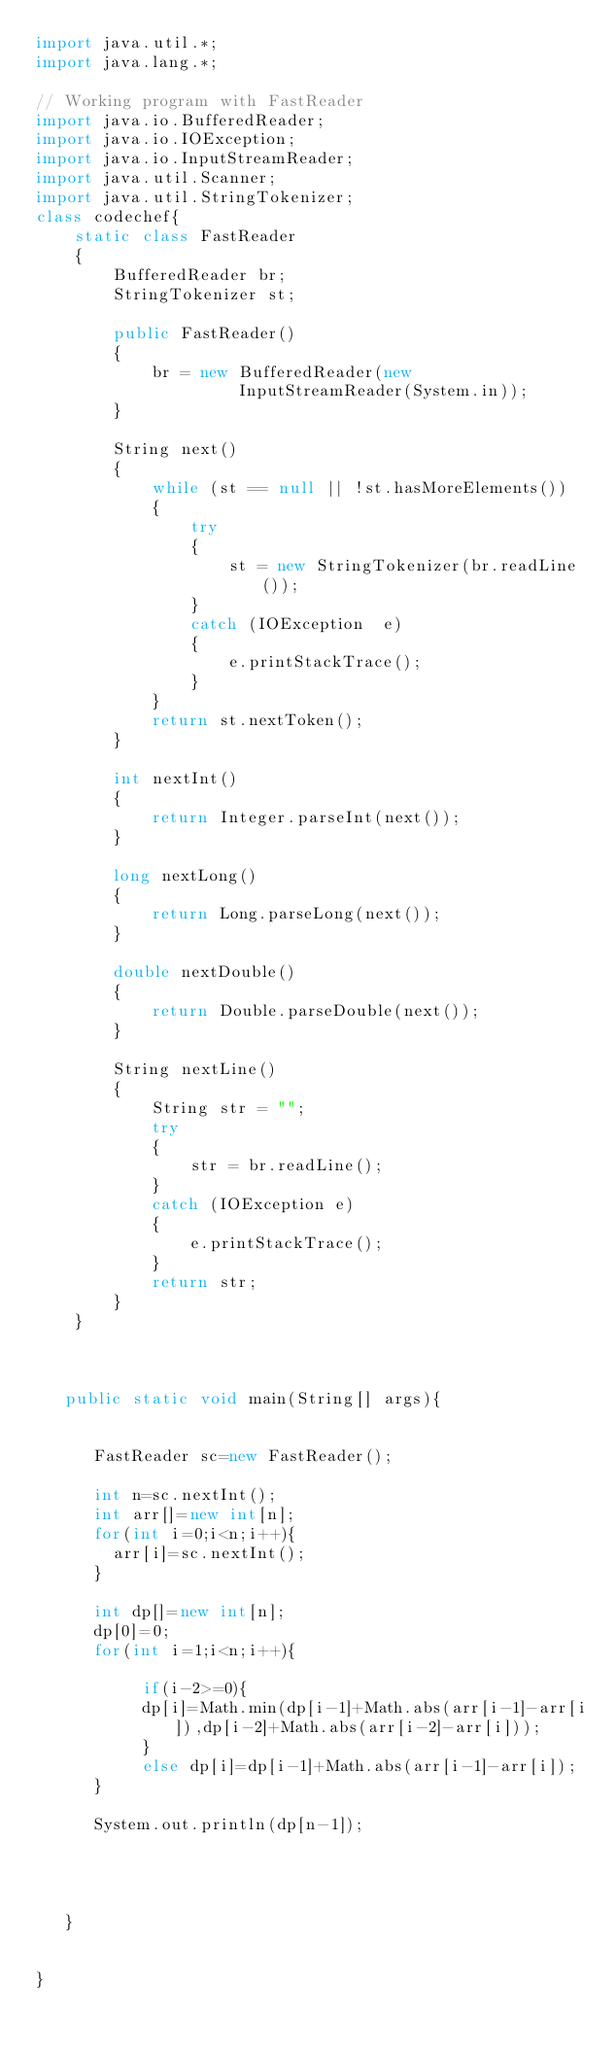<code> <loc_0><loc_0><loc_500><loc_500><_Java_>import java.util.*;
import java.lang.*;

// Working program with FastReader 
import java.io.BufferedReader; 
import java.io.IOException; 
import java.io.InputStreamReader; 
import java.util.Scanner; 
import java.util.StringTokenizer; 
class codechef{
    static class FastReader 
    { 
        BufferedReader br; 
        StringTokenizer st; 
  
        public FastReader() 
        { 
            br = new BufferedReader(new
                     InputStreamReader(System.in)); 
        } 
  
        String next() 
        { 
            while (st == null || !st.hasMoreElements()) 
            { 
                try
                { 
                    st = new StringTokenizer(br.readLine()); 
                } 
                catch (IOException  e) 
                { 
                    e.printStackTrace(); 
                } 
            } 
            return st.nextToken(); 
        } 
  
        int nextInt() 
        { 
            return Integer.parseInt(next()); 
        } 
  
        long nextLong() 
        { 
            return Long.parseLong(next()); 
        } 
  
        double nextDouble() 
        { 
            return Double.parseDouble(next()); 
        } 
  
        String nextLine() 
        { 
            String str = ""; 
            try
            { 
                str = br.readLine(); 
            } 
            catch (IOException e) 
            { 
                e.printStackTrace(); 
            } 
            return str; 
        } 
    }

     

   public static void main(String[] args){

      
      FastReader sc=new FastReader();

      int n=sc.nextInt();
      int arr[]=new int[n];
      for(int i=0;i<n;i++){
        arr[i]=sc.nextInt();
      }

      int dp[]=new int[n];
      dp[0]=0;
      for(int i=1;i<n;i++){

           if(i-2>=0){ 
           dp[i]=Math.min(dp[i-1]+Math.abs(arr[i-1]-arr[i]),dp[i-2]+Math.abs(arr[i-2]-arr[i]));
           }
           else dp[i]=dp[i-1]+Math.abs(arr[i-1]-arr[i]);
      }

      System.out.println(dp[n-1]);



     
   }


}</code> 